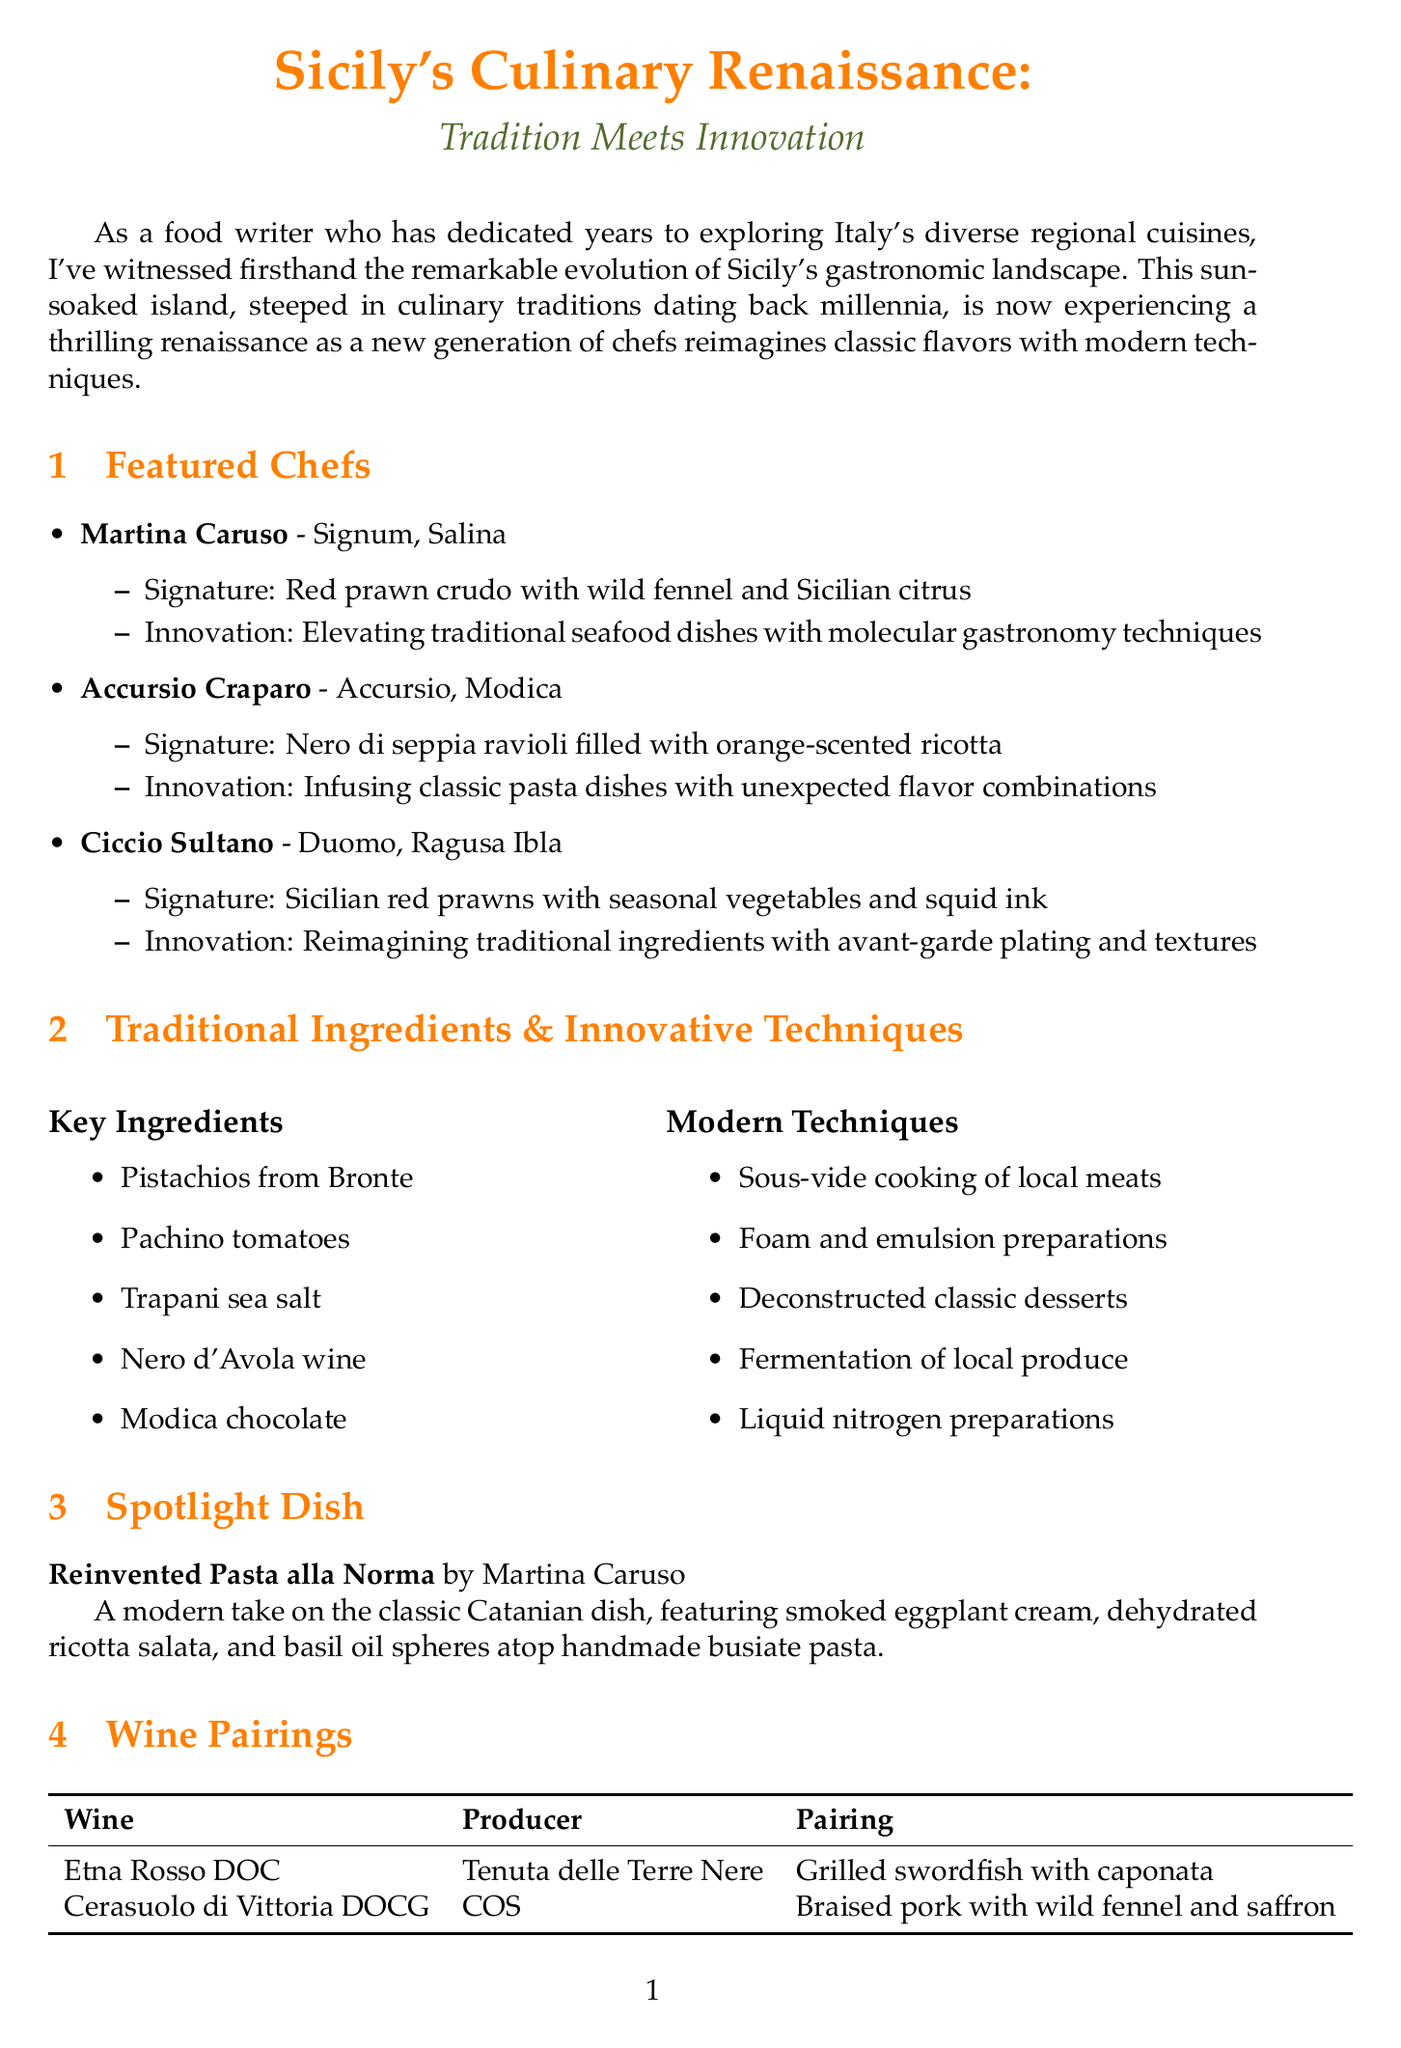What is the title of the newsletter? The title is prominently displayed at the beginning of the document.
Answer: Sicily's Culinary Renaissance: Tradition Meets Innovation Who is the chef associated with the restaurant Signum? This is specified in the section about featured chefs.
Answer: Martina Caruso What is the signature dish of Accursio? This information is provided under the description of Accursio's dishes.
Answer: Nero di seppia ravioli filled with orange-scented ricotta Which traditional ingredient is mentioned that comes from Bronte? This is found in the section listing traditional ingredients.
Answer: Pistachios What culinary festival is scheduled for October 5-8, 2023? The date and name of the festival can be found in the upcoming culinary events section.
Answer: Sherbeth Festival How many featured chefs are highlighted in the newsletter? This requires counting the chefs listed in the featured chefs section.
Answer: Three What innovative technique is mentioned for preparing traditional sauces? This information is detailed in the innovative techniques subsection.
Answer: Foam and emulsion preparations What is the key pairing suggestion for Etna Rosso DOC? This information is included in the wine pairings section.
Answer: Grilled swordfish with caponata Where is the Mercato di Ballarò located? This can be found in the food markets section.
Answer: Palermo 